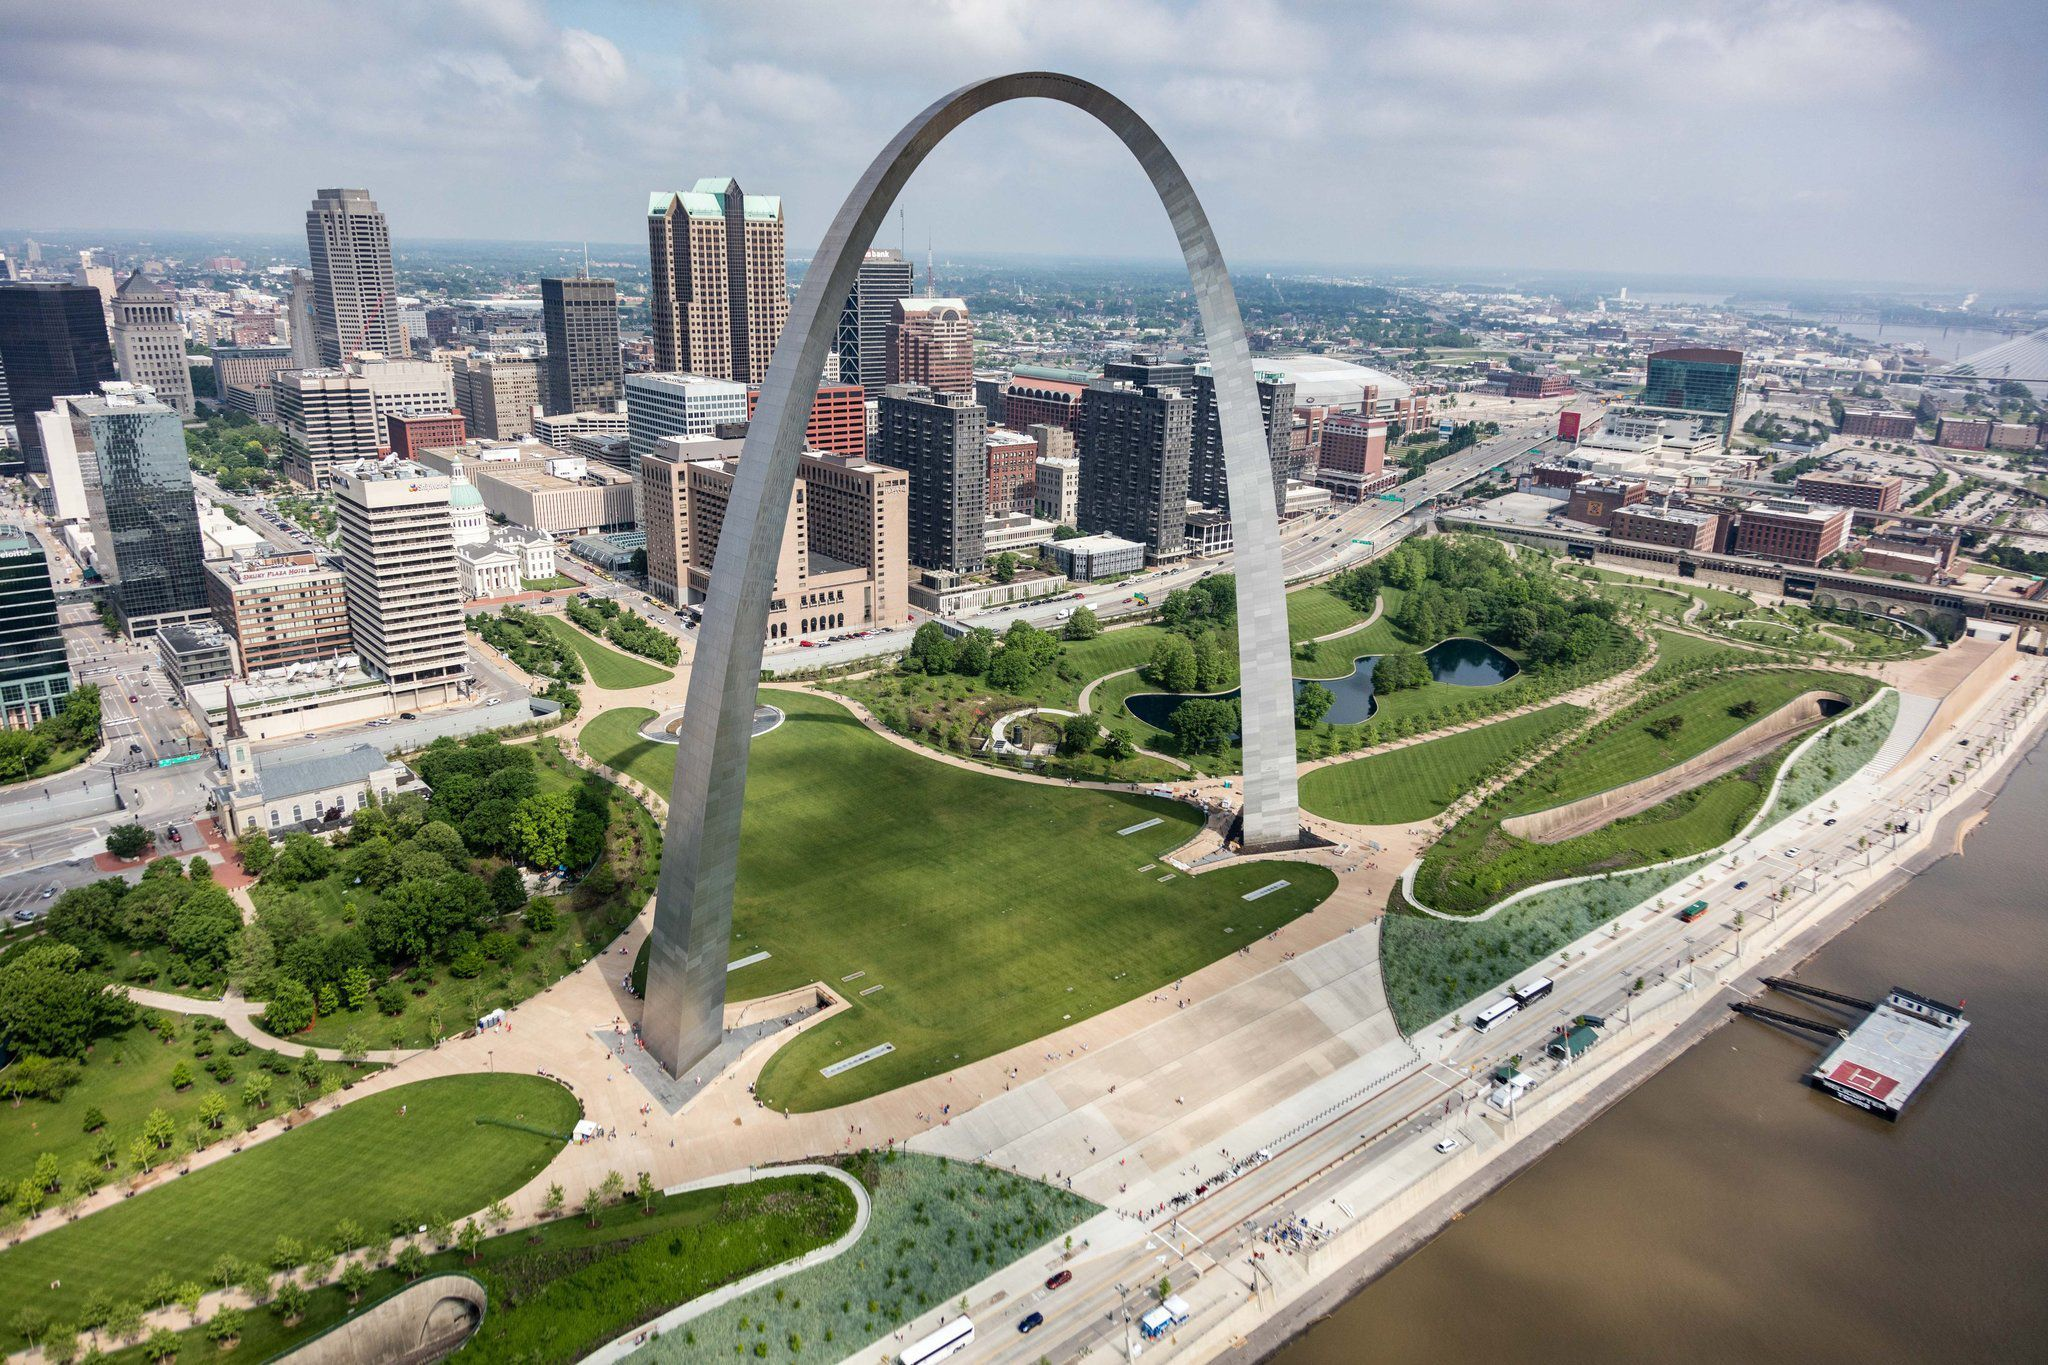Imagine the arch as a portal to another world. Describe what lies beyond. As you step through the Gateway Arch, you are transported to an enchanting realm where the harmonious blend of nature and futuristic architecture stretches as far as the eye can see. Towering trees, their leaves shimmering with an ethereal glow, line the pathways of a bustling metropolis made of translucent structures and floating platforms. Drones and levitating gardens create a mesmerizing dance in the sky. The rivers that wind through this world are not made of water but of flowing light, giving life to the landscape and illuminating the night with soft hues of blue and green. Beyond the horizon, magnificent creatures, a blend of organic and biomechanical forms, soar gracefully through the air. The portal opens a door to a world that thrives on innovation, peace, and a deep connection with nature, offering a glimpse into a utopian future where technology and the environment exist in perfect harmony. 